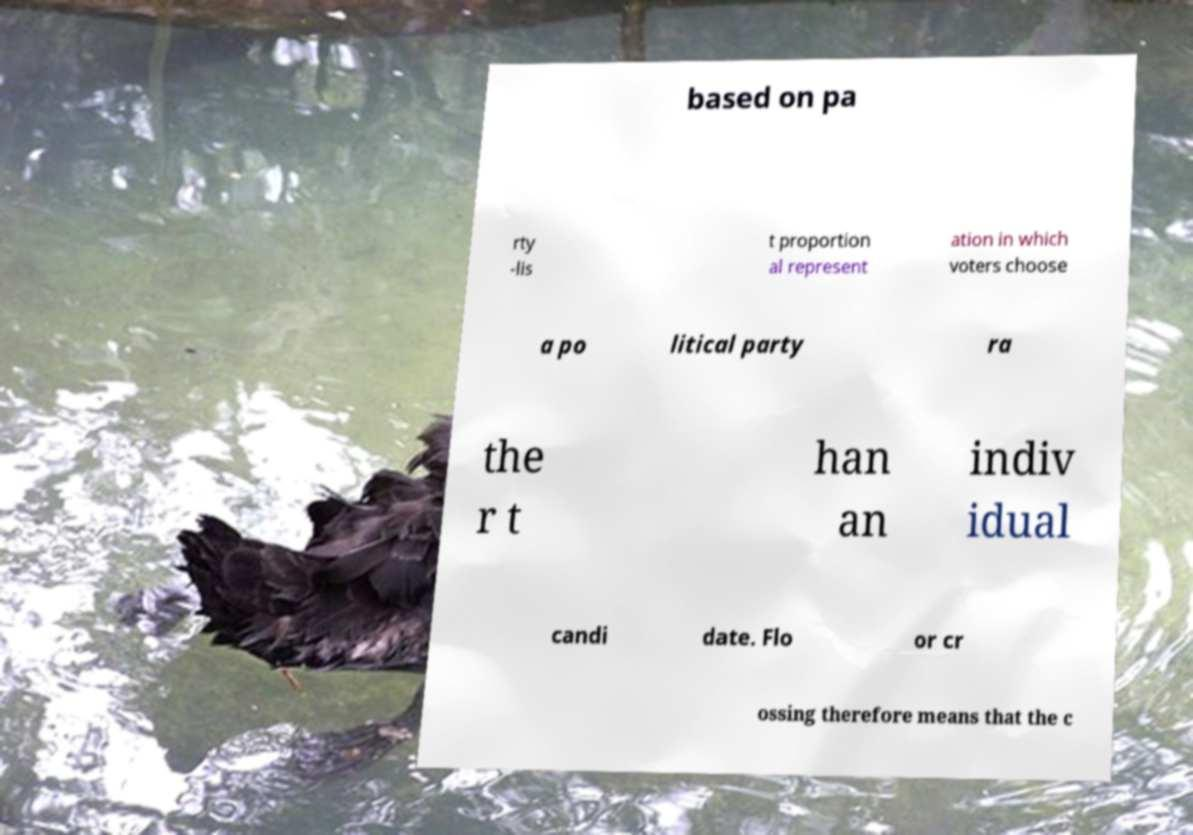Could you assist in decoding the text presented in this image and type it out clearly? based on pa rty -lis t proportion al represent ation in which voters choose a po litical party ra the r t han an indiv idual candi date. Flo or cr ossing therefore means that the c 